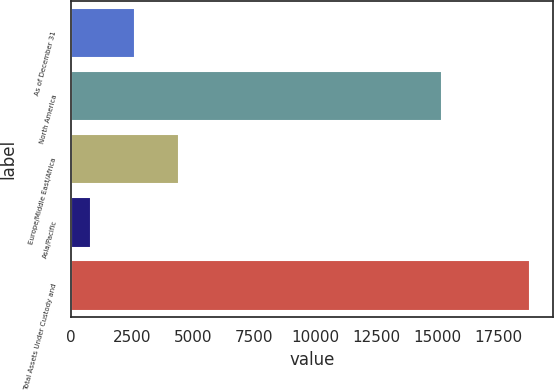Convert chart to OTSL. <chart><loc_0><loc_0><loc_500><loc_500><bar_chart><fcel>As of December 31<fcel>North America<fcel>Europe/Middle East/Africa<fcel>Asia/Pacific<fcel>Total Assets Under Custody and<nl><fcel>2627.4<fcel>15191<fcel>4423.8<fcel>831<fcel>18795<nl></chart> 